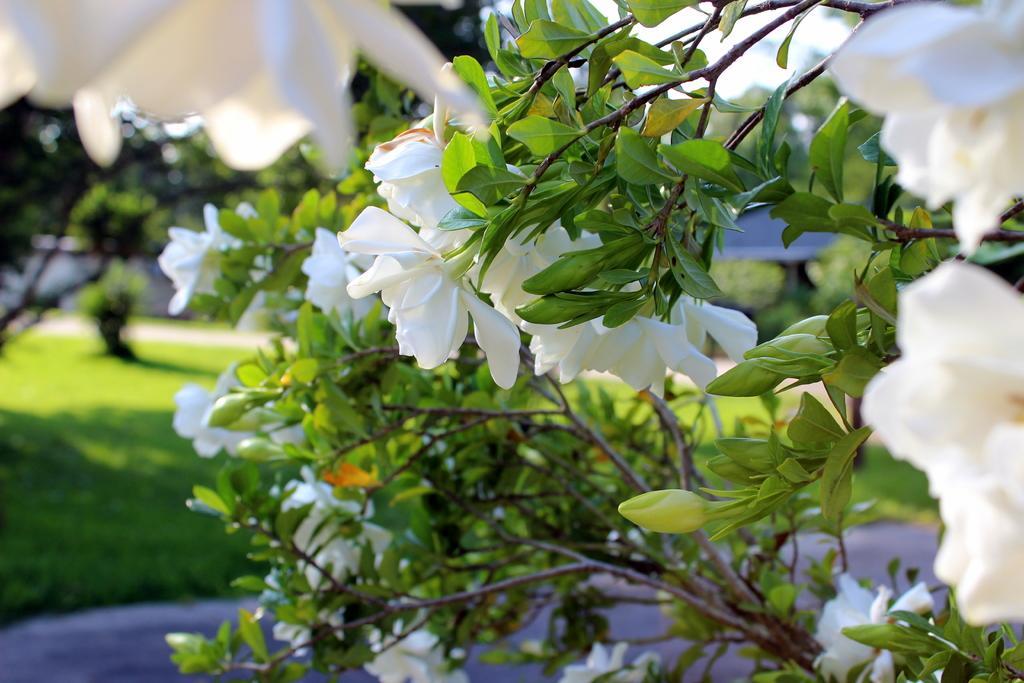Could you give a brief overview of what you see in this image? In the foreground of the picture there are plants, leaves and stems. The background is blurred. In the background there is a greenery and sky. 